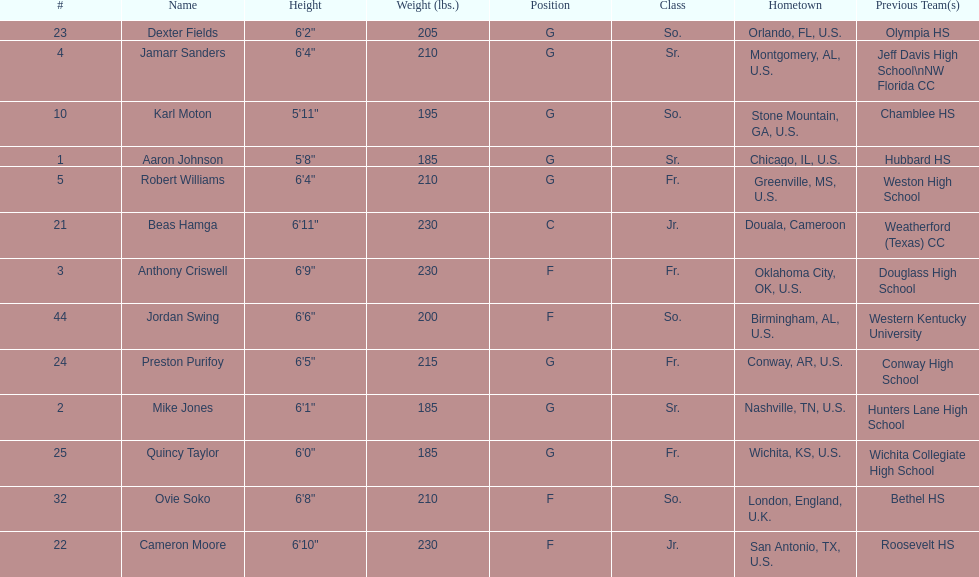What is the average weight of jamarr sanders and robert williams? 210. Could you help me parse every detail presented in this table? {'header': ['#', 'Name', 'Height', 'Weight (lbs.)', 'Position', 'Class', 'Hometown', 'Previous Team(s)'], 'rows': [['23', 'Dexter Fields', '6\'2"', '205', 'G', 'So.', 'Orlando, FL, U.S.', 'Olympia HS'], ['4', 'Jamarr Sanders', '6\'4"', '210', 'G', 'Sr.', 'Montgomery, AL, U.S.', 'Jeff Davis High School\\nNW Florida CC'], ['10', 'Karl Moton', '5\'11"', '195', 'G', 'So.', 'Stone Mountain, GA, U.S.', 'Chamblee HS'], ['1', 'Aaron Johnson', '5\'8"', '185', 'G', 'Sr.', 'Chicago, IL, U.S.', 'Hubbard HS'], ['5', 'Robert Williams', '6\'4"', '210', 'G', 'Fr.', 'Greenville, MS, U.S.', 'Weston High School'], ['21', 'Beas Hamga', '6\'11"', '230', 'C', 'Jr.', 'Douala, Cameroon', 'Weatherford (Texas) CC'], ['3', 'Anthony Criswell', '6\'9"', '230', 'F', 'Fr.', 'Oklahoma City, OK, U.S.', 'Douglass High School'], ['44', 'Jordan Swing', '6\'6"', '200', 'F', 'So.', 'Birmingham, AL, U.S.', 'Western Kentucky University'], ['24', 'Preston Purifoy', '6\'5"', '215', 'G', 'Fr.', 'Conway, AR, U.S.', 'Conway High School'], ['2', 'Mike Jones', '6\'1"', '185', 'G', 'Sr.', 'Nashville, TN, U.S.', 'Hunters Lane High School'], ['25', 'Quincy Taylor', '6\'0"', '185', 'G', 'Fr.', 'Wichita, KS, U.S.', 'Wichita Collegiate High School'], ['32', 'Ovie Soko', '6\'8"', '210', 'F', 'So.', 'London, England, U.K.', 'Bethel HS'], ['22', 'Cameron Moore', '6\'10"', '230', 'F', 'Jr.', 'San Antonio, TX, U.S.', 'Roosevelt HS']]} 